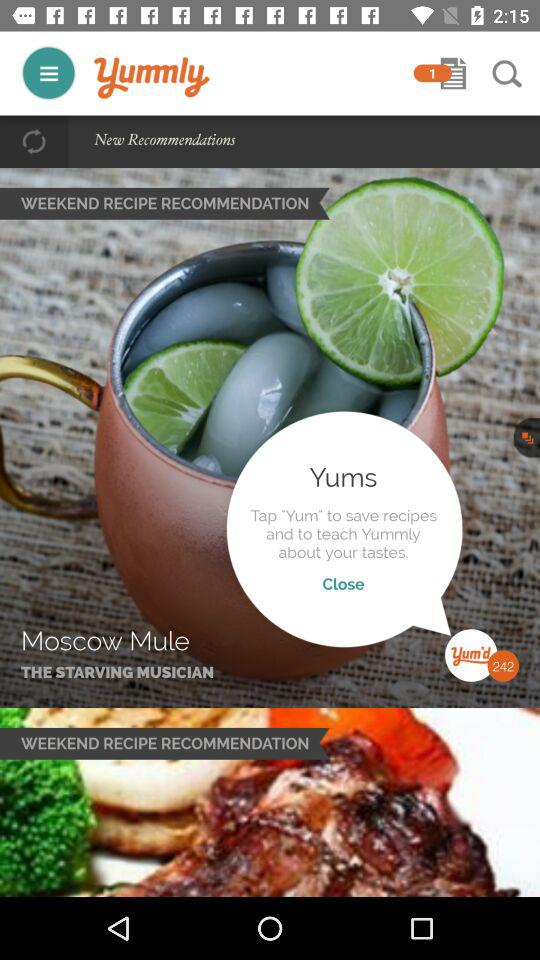How many messages were unread? There was 1 unread message. 